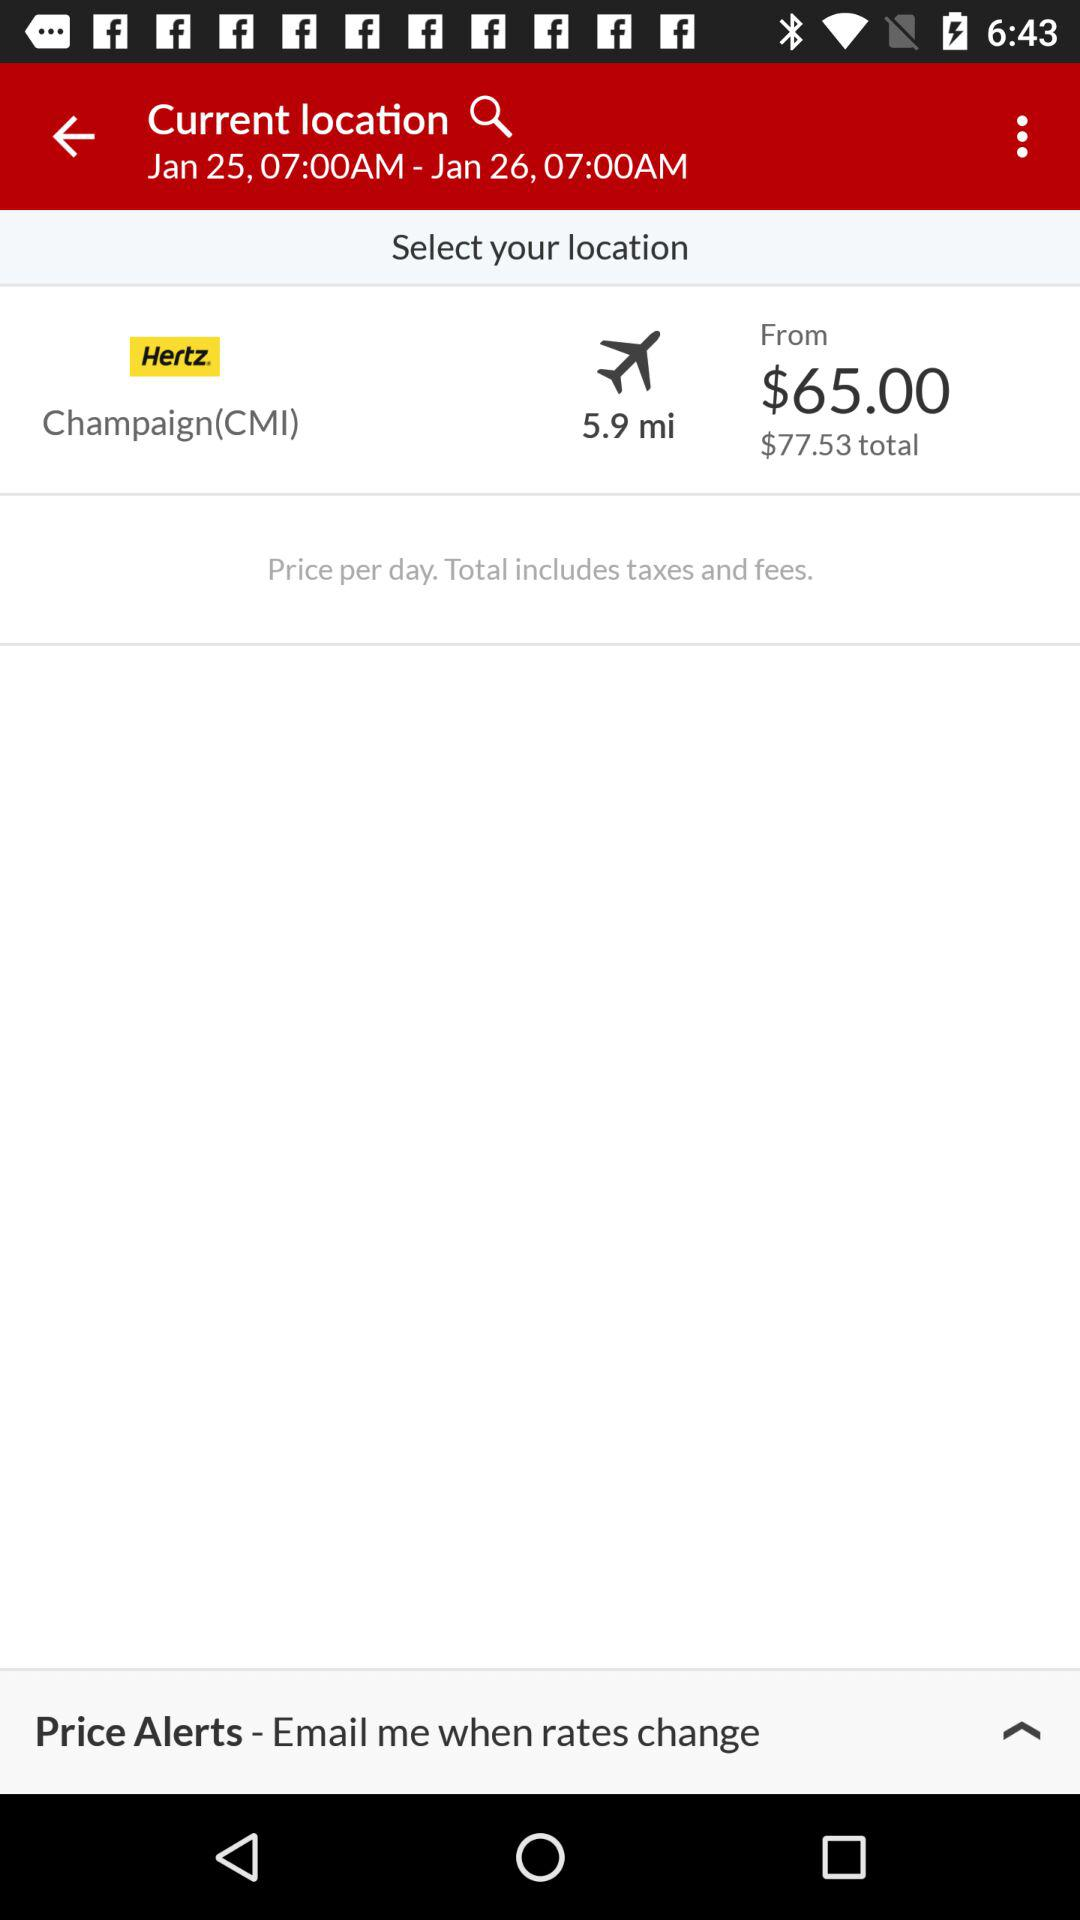What is the total price? The total price is $77.53. 